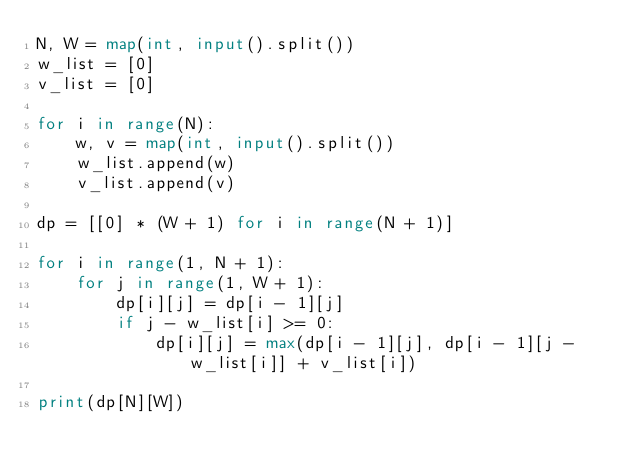<code> <loc_0><loc_0><loc_500><loc_500><_Python_>N, W = map(int, input().split())
w_list = [0]
v_list = [0]

for i in range(N):
    w, v = map(int, input().split())
    w_list.append(w)
    v_list.append(v)
    
dp = [[0] * (W + 1) for i in range(N + 1)]

for i in range(1, N + 1):
    for j in range(1, W + 1):
        dp[i][j] = dp[i - 1][j]
        if j - w_list[i] >= 0:
            dp[i][j] = max(dp[i - 1][j], dp[i - 1][j - w_list[i]] + v_list[i])
        
print(dp[N][W])</code> 